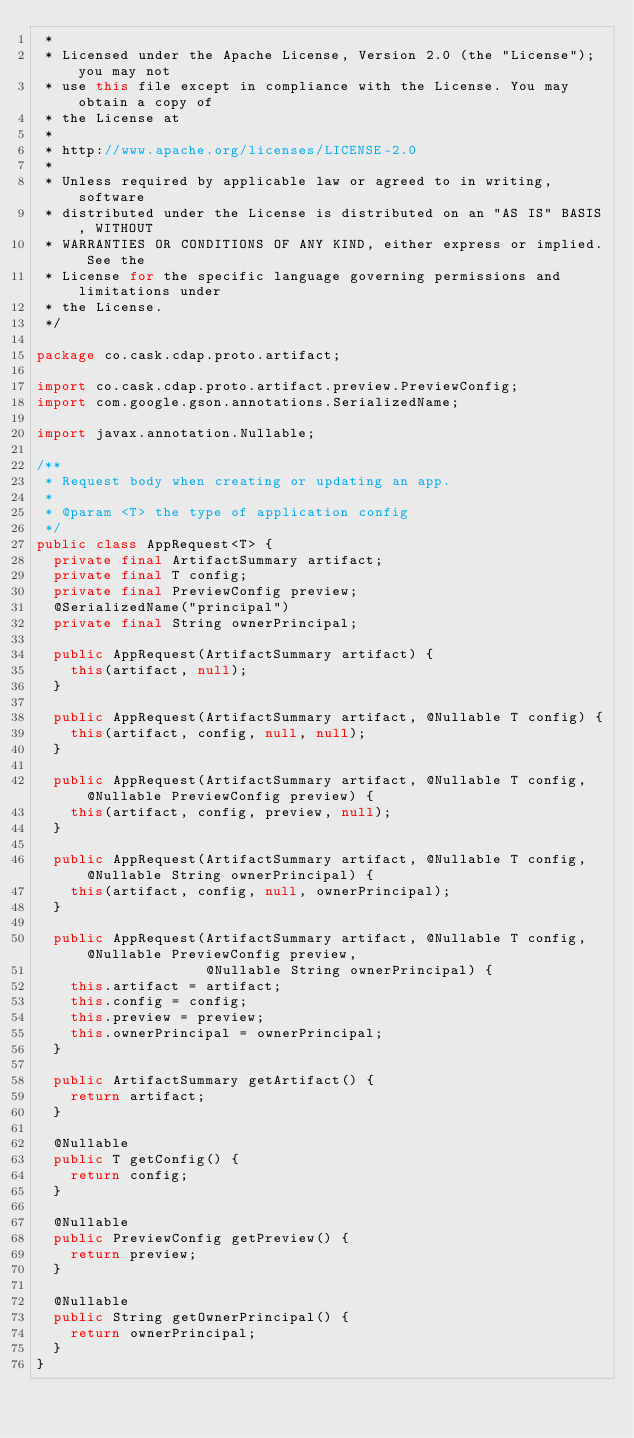Convert code to text. <code><loc_0><loc_0><loc_500><loc_500><_Java_> *
 * Licensed under the Apache License, Version 2.0 (the "License"); you may not
 * use this file except in compliance with the License. You may obtain a copy of
 * the License at
 *
 * http://www.apache.org/licenses/LICENSE-2.0
 *
 * Unless required by applicable law or agreed to in writing, software
 * distributed under the License is distributed on an "AS IS" BASIS, WITHOUT
 * WARRANTIES OR CONDITIONS OF ANY KIND, either express or implied. See the
 * License for the specific language governing permissions and limitations under
 * the License.
 */

package co.cask.cdap.proto.artifact;

import co.cask.cdap.proto.artifact.preview.PreviewConfig;
import com.google.gson.annotations.SerializedName;

import javax.annotation.Nullable;

/**
 * Request body when creating or updating an app.
 *
 * @param <T> the type of application config
 */
public class AppRequest<T> {
  private final ArtifactSummary artifact;
  private final T config;
  private final PreviewConfig preview;
  @SerializedName("principal")
  private final String ownerPrincipal;

  public AppRequest(ArtifactSummary artifact) {
    this(artifact, null);
  }

  public AppRequest(ArtifactSummary artifact, @Nullable T config) {
    this(artifact, config, null, null);
  }

  public AppRequest(ArtifactSummary artifact, @Nullable T config, @Nullable PreviewConfig preview) {
    this(artifact, config, preview, null);
  }

  public AppRequest(ArtifactSummary artifact, @Nullable T config, @Nullable String ownerPrincipal) {
    this(artifact, config, null, ownerPrincipal);
  }

  public AppRequest(ArtifactSummary artifact, @Nullable T config, @Nullable PreviewConfig preview,
                    @Nullable String ownerPrincipal) {
    this.artifact = artifact;
    this.config = config;
    this.preview = preview;
    this.ownerPrincipal = ownerPrincipal;
  }

  public ArtifactSummary getArtifact() {
    return artifact;
  }

  @Nullable
  public T getConfig() {
    return config;
  }

  @Nullable
  public PreviewConfig getPreview() {
    return preview;
  }

  @Nullable
  public String getOwnerPrincipal() {
    return ownerPrincipal;
  }
}
</code> 